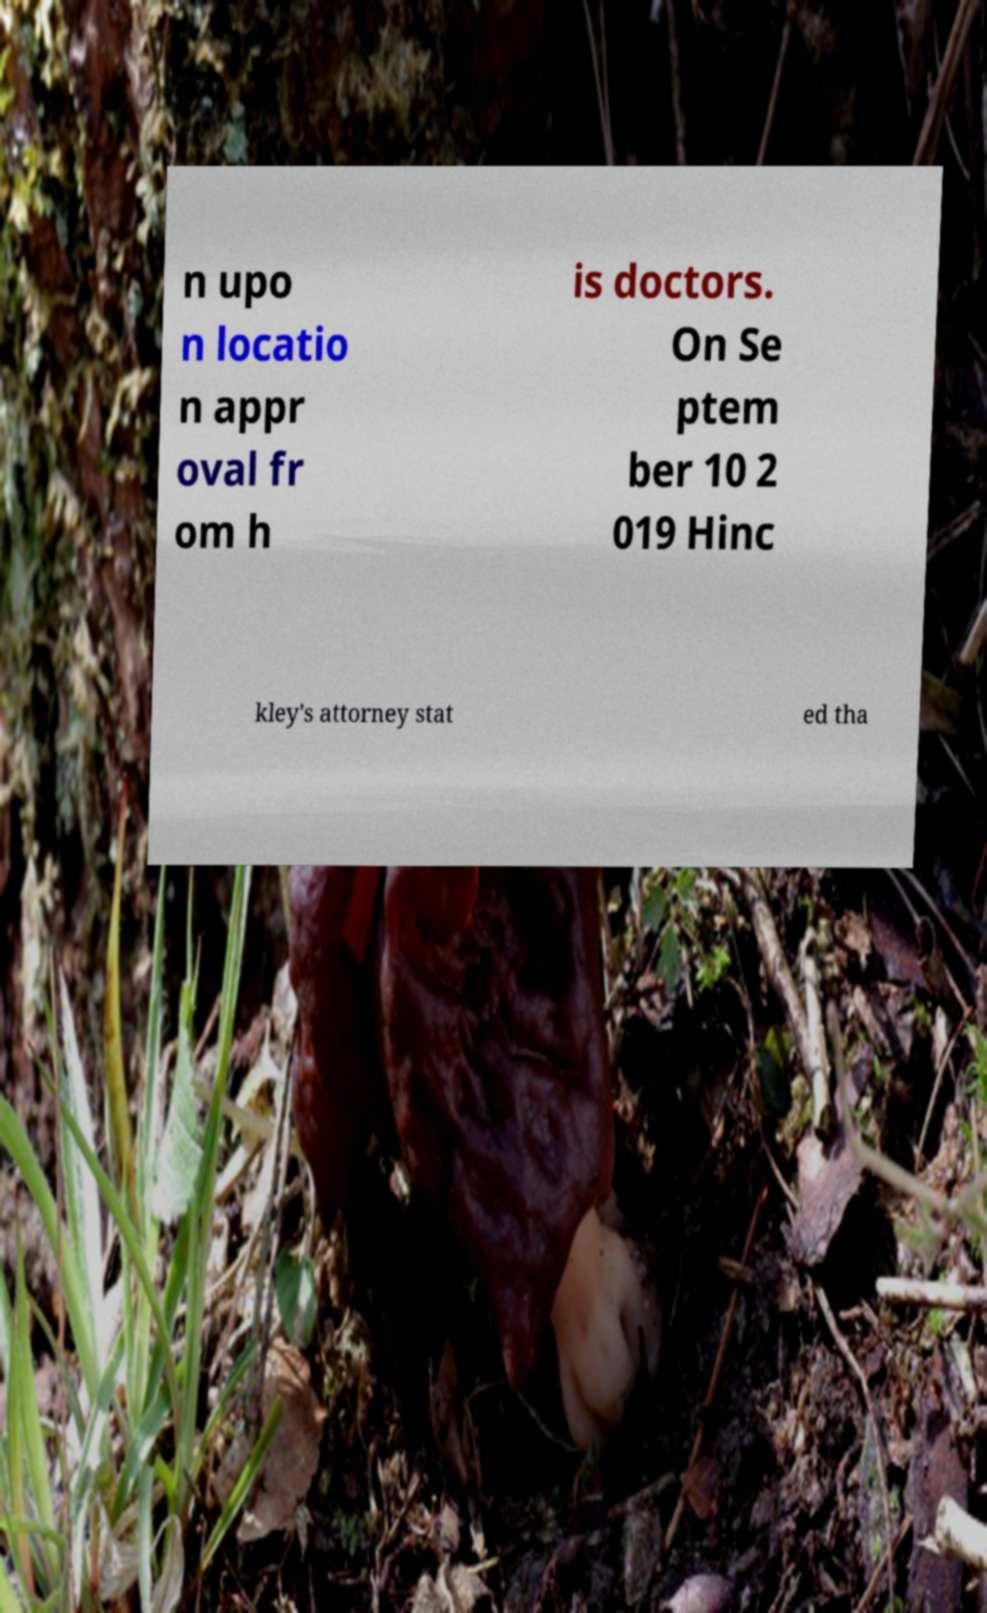Please read and relay the text visible in this image. What does it say? n upo n locatio n appr oval fr om h is doctors. On Se ptem ber 10 2 019 Hinc kley's attorney stat ed tha 